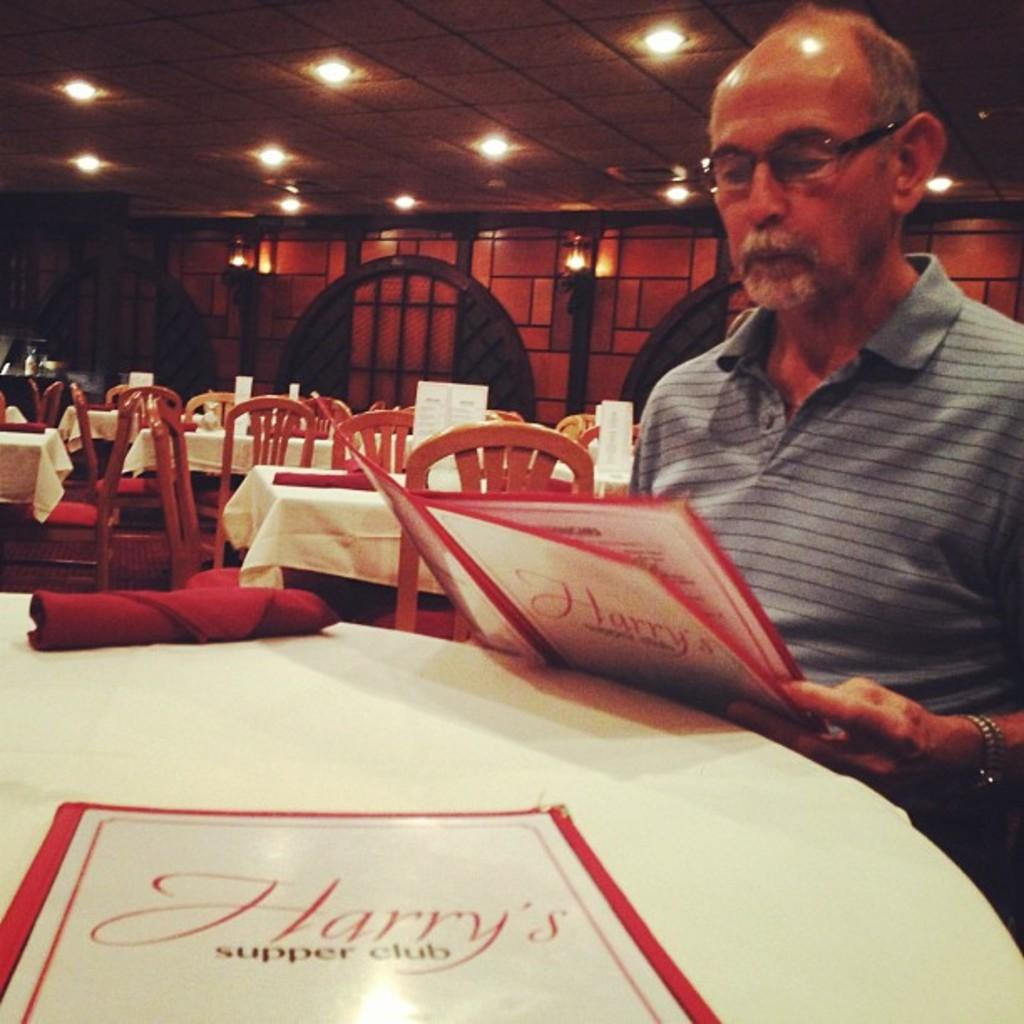What is the man in the image doing? The man is sitting in the image. What is the man holding in the image? The man is holding a menu card. What type of furniture can be seen in the image? There are tables and chairs in the image. What items might be used for cleaning or wiping in the image? Napkins are present in the image. What type of signage is visible in the image? There are boards in the image. What is visible at the top of the image? Lights are visible at the top of the image. What type of hair is visible on the man's head in the image? There is no information about the man's hair in the provided facts, so we cannot determine the type of hair visible on his head. 